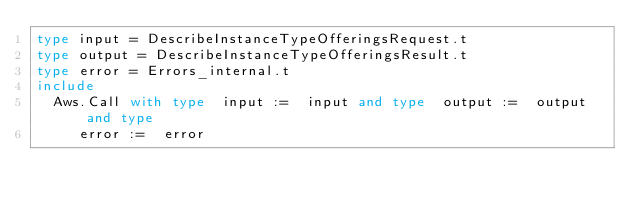Convert code to text. <code><loc_0><loc_0><loc_500><loc_500><_OCaml_>type input = DescribeInstanceTypeOfferingsRequest.t
type output = DescribeInstanceTypeOfferingsResult.t
type error = Errors_internal.t
include
  Aws.Call with type  input :=  input and type  output :=  output and type
     error :=  error</code> 